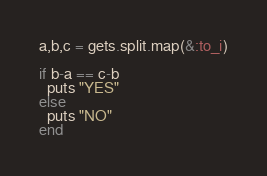Convert code to text. <code><loc_0><loc_0><loc_500><loc_500><_Ruby_>a,b,c = gets.split.map(&:to_i)

if b-a == c-b
  puts "YES"
else
  puts "NO"
end
</code> 